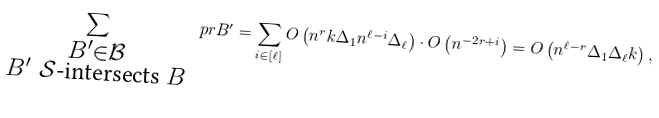Convert formula to latex. <formula><loc_0><loc_0><loc_500><loc_500>\sum _ { \substack { B ^ { \prime } \in \mathcal { B } \\ B ^ { \prime } \ \mathcal { S } \text {-intersects } B } } \ p r { B ^ { \prime } } = \sum _ { i \in [ \ell ] } O \left ( n ^ { r } k \Delta _ { 1 } n ^ { \ell - i } \Delta _ { \ell } \right ) \cdot O \left ( n ^ { - 2 r + i } \right ) = O \left ( n ^ { \ell - r } \Delta _ { 1 } \Delta _ { \ell } k \right ) ,</formula> 